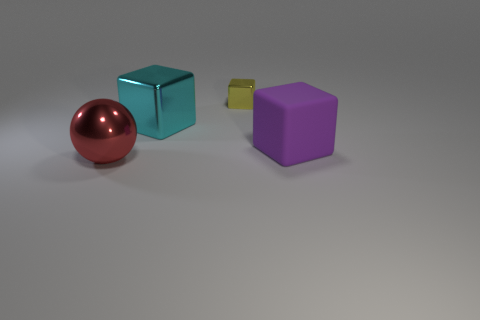Add 1 yellow matte objects. How many objects exist? 5 Subtract all blocks. How many objects are left? 1 Subtract all red metal spheres. Subtract all yellow metal things. How many objects are left? 2 Add 3 large metallic cubes. How many large metallic cubes are left? 4 Add 3 cyan metallic blocks. How many cyan metallic blocks exist? 4 Subtract 0 brown blocks. How many objects are left? 4 